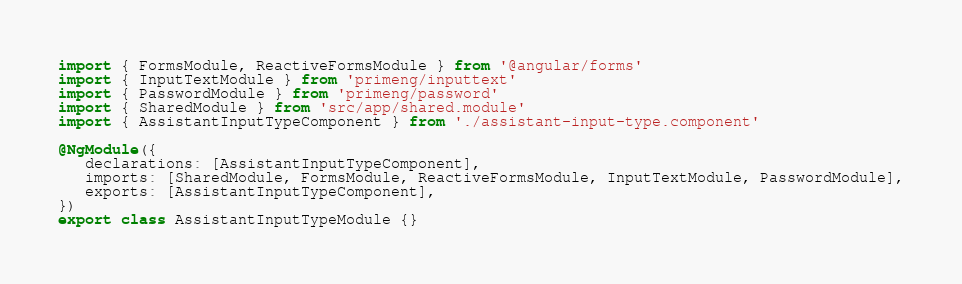<code> <loc_0><loc_0><loc_500><loc_500><_TypeScript_>import { FormsModule, ReactiveFormsModule } from '@angular/forms'
import { InputTextModule } from 'primeng/inputtext'
import { PasswordModule } from 'primeng/password'
import { SharedModule } from 'src/app/shared.module'
import { AssistantInputTypeComponent } from './assistant-input-type.component'

@NgModule({
   declarations: [AssistantInputTypeComponent],
   imports: [SharedModule, FormsModule, ReactiveFormsModule, InputTextModule, PasswordModule],
   exports: [AssistantInputTypeComponent],
})
export class AssistantInputTypeModule {}
</code> 